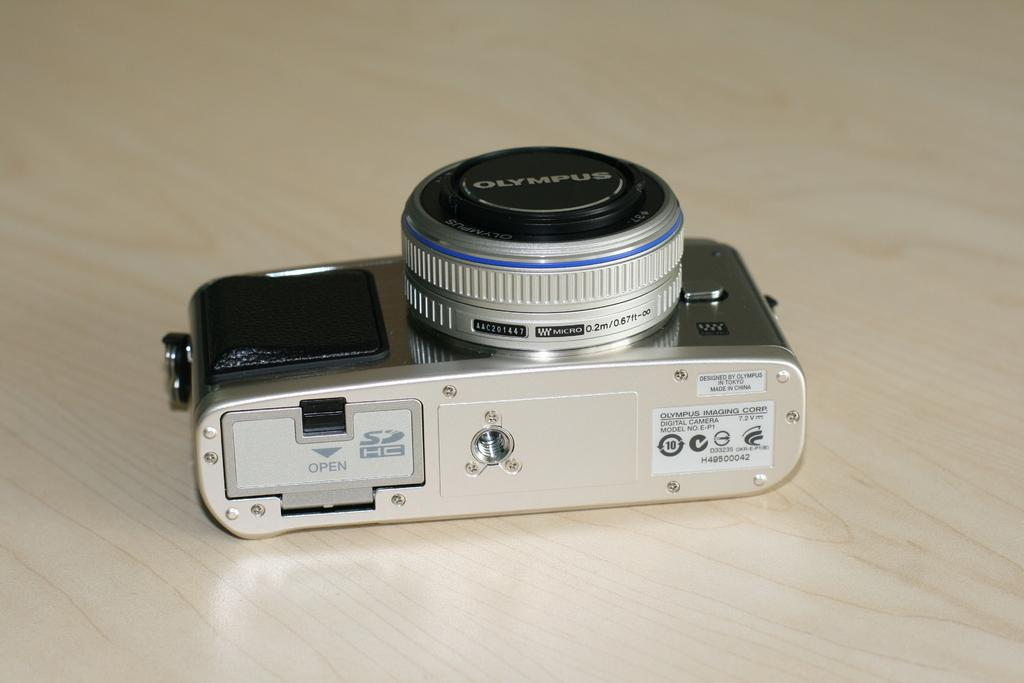What object is the main focus of the image? There is a camera in the image. Where is the camera located? The camera is on a table. What colors can be seen on the camera? The camera is black and silver in color. How many sheep are visible in the image? There are no sheep present in the image. What level of detail can be seen on the camera lens in the image? The level of detail on the camera lens cannot be determined from the image, as the image does not provide a close-up view of the lens. 